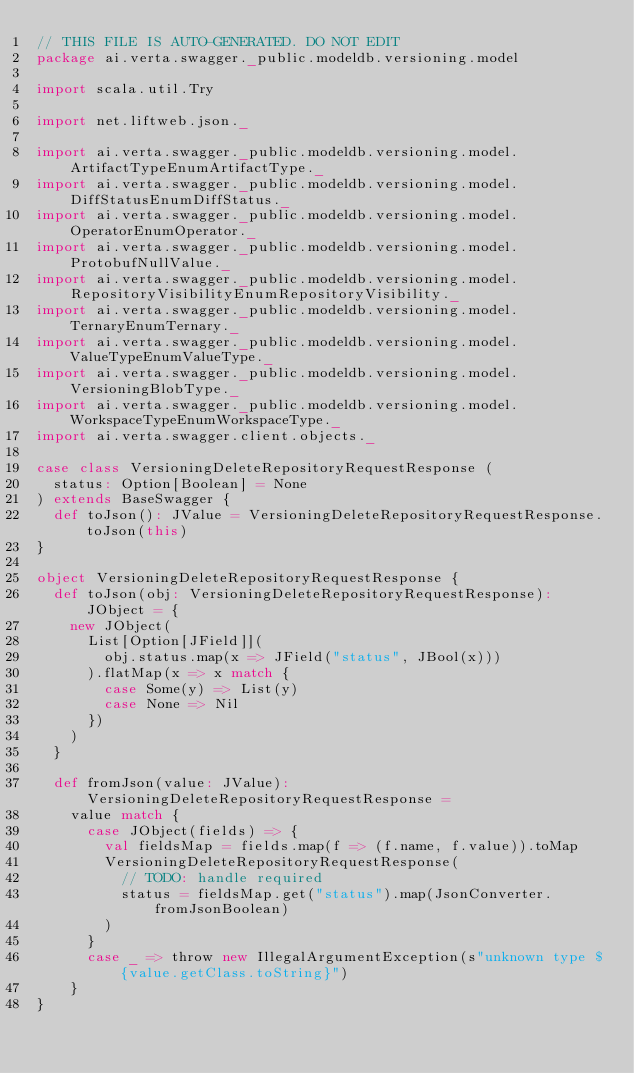<code> <loc_0><loc_0><loc_500><loc_500><_Scala_>// THIS FILE IS AUTO-GENERATED. DO NOT EDIT
package ai.verta.swagger._public.modeldb.versioning.model

import scala.util.Try

import net.liftweb.json._

import ai.verta.swagger._public.modeldb.versioning.model.ArtifactTypeEnumArtifactType._
import ai.verta.swagger._public.modeldb.versioning.model.DiffStatusEnumDiffStatus._
import ai.verta.swagger._public.modeldb.versioning.model.OperatorEnumOperator._
import ai.verta.swagger._public.modeldb.versioning.model.ProtobufNullValue._
import ai.verta.swagger._public.modeldb.versioning.model.RepositoryVisibilityEnumRepositoryVisibility._
import ai.verta.swagger._public.modeldb.versioning.model.TernaryEnumTernary._
import ai.verta.swagger._public.modeldb.versioning.model.ValueTypeEnumValueType._
import ai.verta.swagger._public.modeldb.versioning.model.VersioningBlobType._
import ai.verta.swagger._public.modeldb.versioning.model.WorkspaceTypeEnumWorkspaceType._
import ai.verta.swagger.client.objects._

case class VersioningDeleteRepositoryRequestResponse (
  status: Option[Boolean] = None
) extends BaseSwagger {
  def toJson(): JValue = VersioningDeleteRepositoryRequestResponse.toJson(this)
}

object VersioningDeleteRepositoryRequestResponse {
  def toJson(obj: VersioningDeleteRepositoryRequestResponse): JObject = {
    new JObject(
      List[Option[JField]](
        obj.status.map(x => JField("status", JBool(x)))
      ).flatMap(x => x match {
        case Some(y) => List(y)
        case None => Nil
      })
    )
  }

  def fromJson(value: JValue): VersioningDeleteRepositoryRequestResponse =
    value match {
      case JObject(fields) => {
        val fieldsMap = fields.map(f => (f.name, f.value)).toMap
        VersioningDeleteRepositoryRequestResponse(
          // TODO: handle required
          status = fieldsMap.get("status").map(JsonConverter.fromJsonBoolean)
        )
      }
      case _ => throw new IllegalArgumentException(s"unknown type ${value.getClass.toString}")
    }
}
</code> 